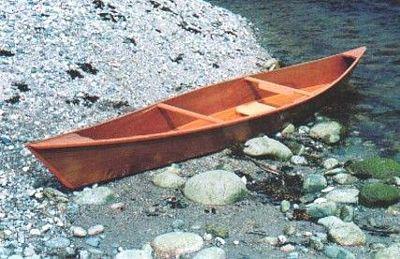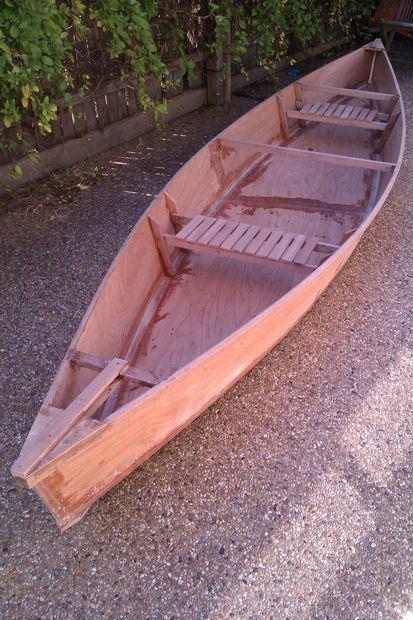The first image is the image on the left, the second image is the image on the right. Assess this claim about the two images: "At least one boat is partially on land and partially in water.". Correct or not? Answer yes or no. Yes. The first image is the image on the left, the second image is the image on the right. Examine the images to the left and right. Is the description "One image shows a brown canoe floating on water, and the other image shows one canoe sitting on dry ground with no water in sight." accurate? Answer yes or no. No. 